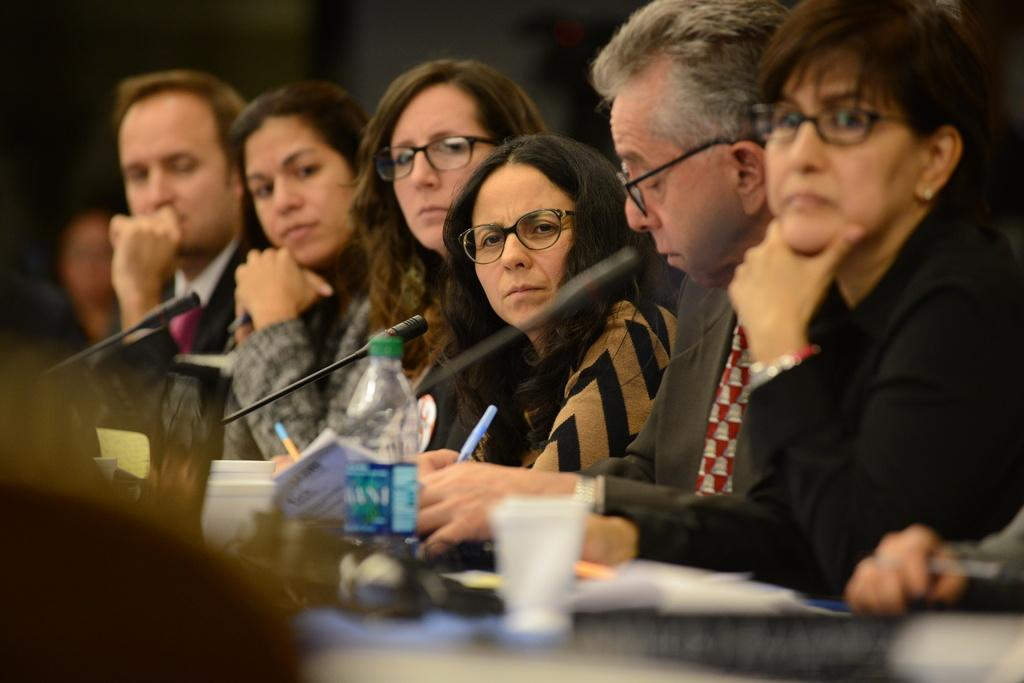How many people are in front of the table in the image? There are many people in front of the table in the image. What items can be seen on the table? There are books, microphones, a bottle, and other unspecified items on the table. What might the people be using the microphones for? The microphones might be used for speaking or recording, given their presence on the table. What type of nail is being hammered into the sheet in the image? There is no nail or sheet present in the image; the image features a table with books, microphones, a bottle, and other unspecified items, along with many people in front of the table. 